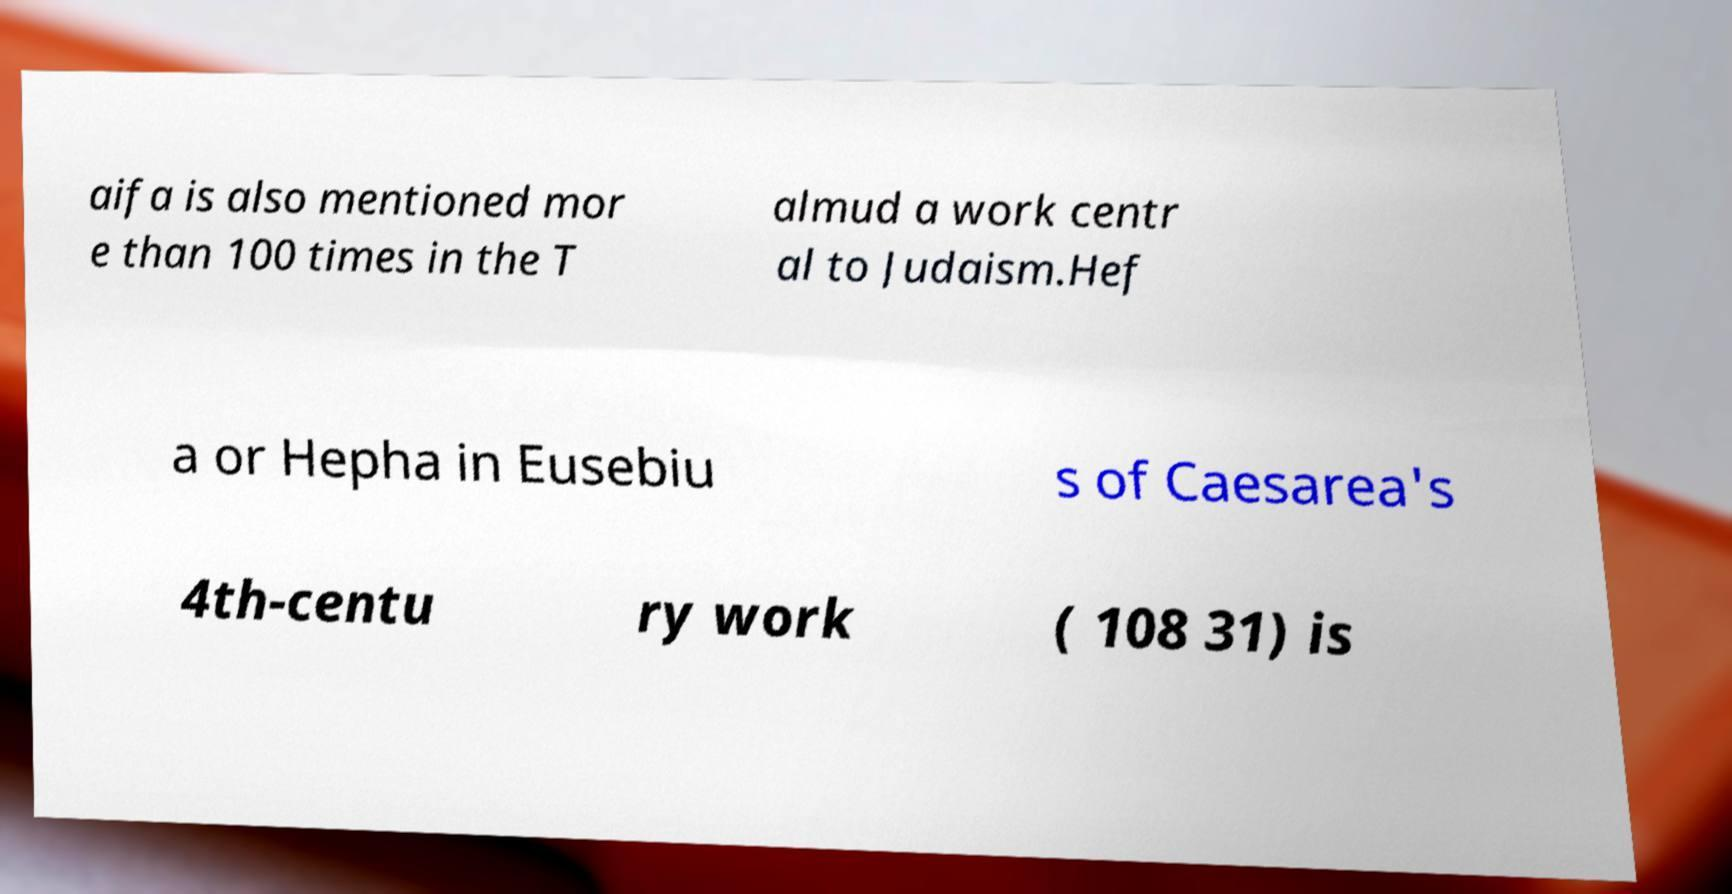Could you assist in decoding the text presented in this image and type it out clearly? aifa is also mentioned mor e than 100 times in the T almud a work centr al to Judaism.Hef a or Hepha in Eusebiu s of Caesarea's 4th-centu ry work ( 108 31) is 